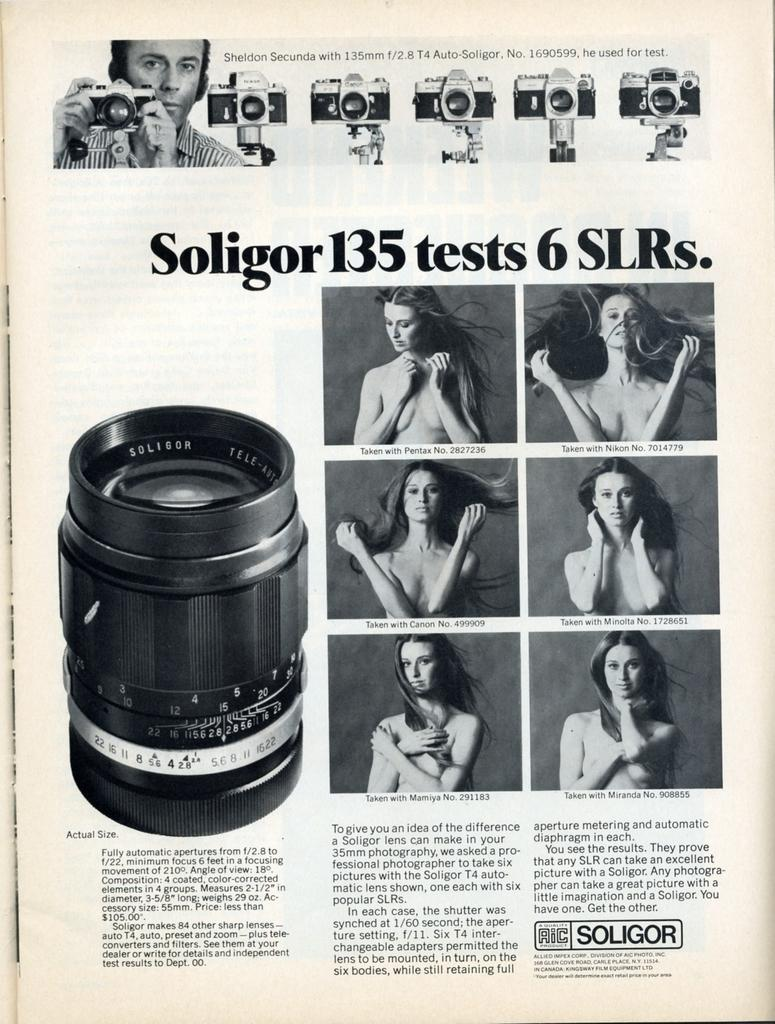What is the primary subject of the paper in the image? The paper contains images of a woman, a camera, and a man. What type of images are depicted on the paper? The paper contains images of a woman, a camera, and a man. Is there any text present on the paper? Yes, there is text on the paper. Can you tell me how many kittens are comfortably sitting by the river in the image? There are no kittens or rivers present in the image; it features a paper with images and text. 